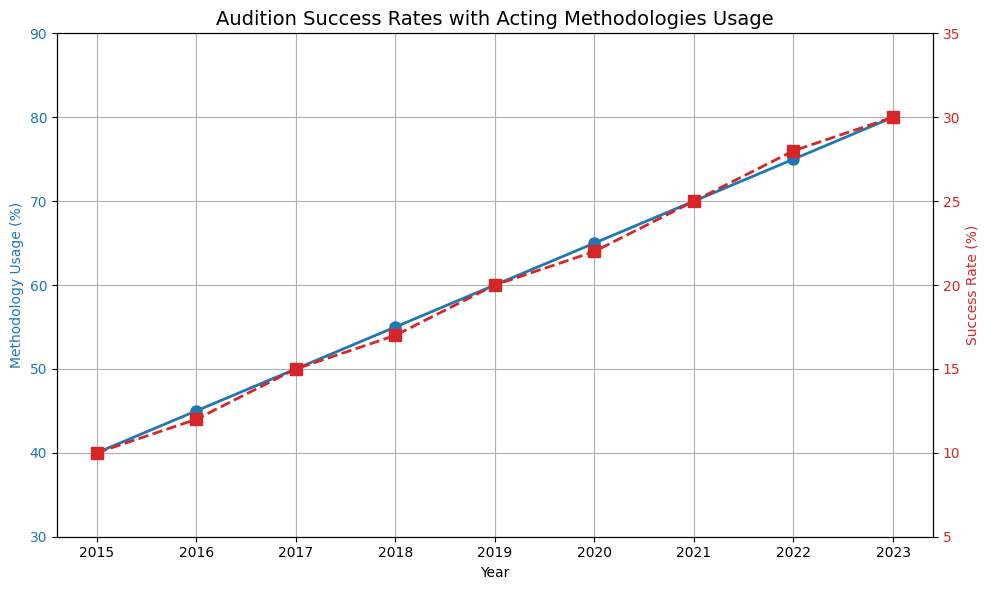Which year had the highest success rate? Look at the "Success Rate (%)" line plot (red) and find the year with the highest point. The highest point corresponds to the year 2023 with a success rate of 30%.
Answer: 2023 How much did the methodology usage increase from 2015 to 2023? Find the "Methodology Usage (%)" values for 2015 and 2023. The values are 40 and 80, respectively. The increase is 80 - 40 = 40%.
Answer: 40% What is the average success rate across all years? Sum up the success rates for all given years and divide by the number of years. (10 + 12 + 15 + 17 + 20 + 22 + 25 + 28 + 30) / 9 ≈ 19.89%.
Answer: 19.89% In which year was the gap between methodology usage and success rate the smallest? Calculate the absolute difference between methodology usage and success rate for each year. The differences are: 
2015: 30, 2016: 33, 2017: 35, 2018: 38, 2019: 40, 2020: 43, 2021: 45, 2022: 47, 2023: 50. The smallest difference is in 2015.
Answer: 2015 Which had a greater increase from 2015 to 2023, methodology usage or success rate? Calculate the increase for both measures from 2015 to 2023. Methodology Usage increased from 40 to 80 (an increase of 40), and Success Rate increased from 10 to 30 (an increase of 20). Methodology usage had a greater increase.
Answer: Methodology usage What is the success rate when the methodology usage is 70%? Look at the data or plot where Methodology Usage (%) is 70. The corresponding Success Rate (%) is 25%.
Answer: 25% In what year did methodology usage reach 55%? Look for the year when the "Methodology Usage (%)" value is 55. According to the data, it was in 2018.
Answer: 2018 What is the rate of increase in success rate from 2015 to 2023? Find the initial and final values of the success rate (10% in 2015 and 30% in 2023). The rate of increase is (30 - 10) / 10 * 100% = 200%.
Answer: 200% Compare the success rates in 2017 and 2019. Which year had a higher rate, and by how much? Look at the red line (success rate) for 2017 and 2019. The rates are 15% and 20%, respectively. 2019 had a higher rate by 20 - 15 = 5%.
Answer: 2019, 5% higher 